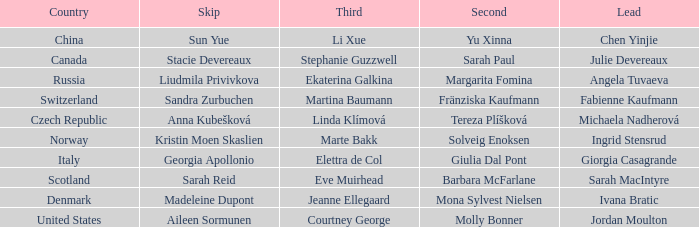Give me the full table as a dictionary. {'header': ['Country', 'Skip', 'Third', 'Second', 'Lead'], 'rows': [['China', 'Sun Yue', 'Li Xue', 'Yu Xinna', 'Chen Yinjie'], ['Canada', 'Stacie Devereaux', 'Stephanie Guzzwell', 'Sarah Paul', 'Julie Devereaux'], ['Russia', 'Liudmila Privivkova', 'Ekaterina Galkina', 'Margarita Fomina', 'Angela Tuvaeva'], ['Switzerland', 'Sandra Zurbuchen', 'Martina Baumann', 'Fränziska Kaufmann', 'Fabienne Kaufmann'], ['Czech Republic', 'Anna Kubešková', 'Linda Klímová', 'Tereza Plíšková', 'Michaela Nadherová'], ['Norway', 'Kristin Moen Skaslien', 'Marte Bakk', 'Solveig Enoksen', 'Ingrid Stensrud'], ['Italy', 'Georgia Apollonio', 'Elettra de Col', 'Giulia Dal Pont', 'Giorgia Casagrande'], ['Scotland', 'Sarah Reid', 'Eve Muirhead', 'Barbara McFarlane', 'Sarah MacIntyre'], ['Denmark', 'Madeleine Dupont', 'Jeanne Ellegaard', 'Mona Sylvest Nielsen', 'Ivana Bratic'], ['United States', 'Aileen Sormunen', 'Courtney George', 'Molly Bonner', 'Jordan Moulton']]} What skip has denmark as the country? Madeleine Dupont. 